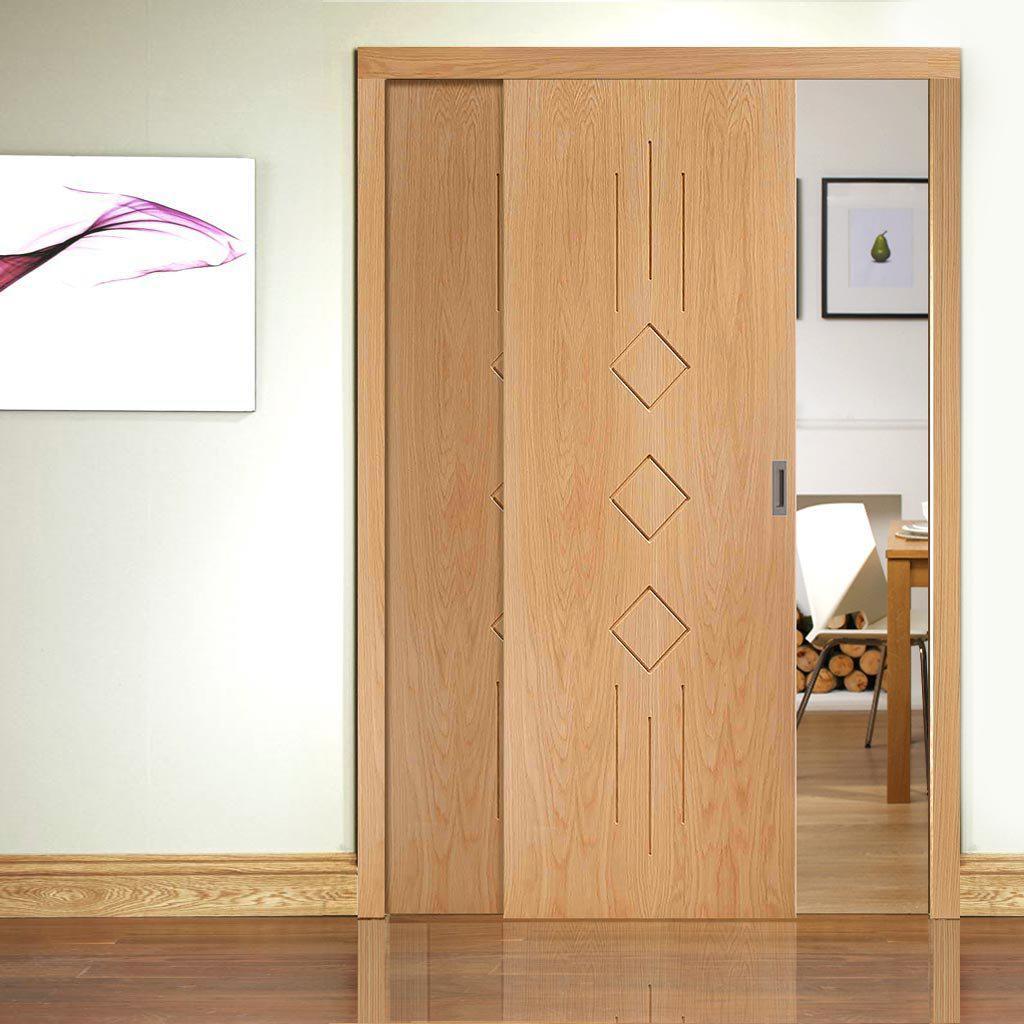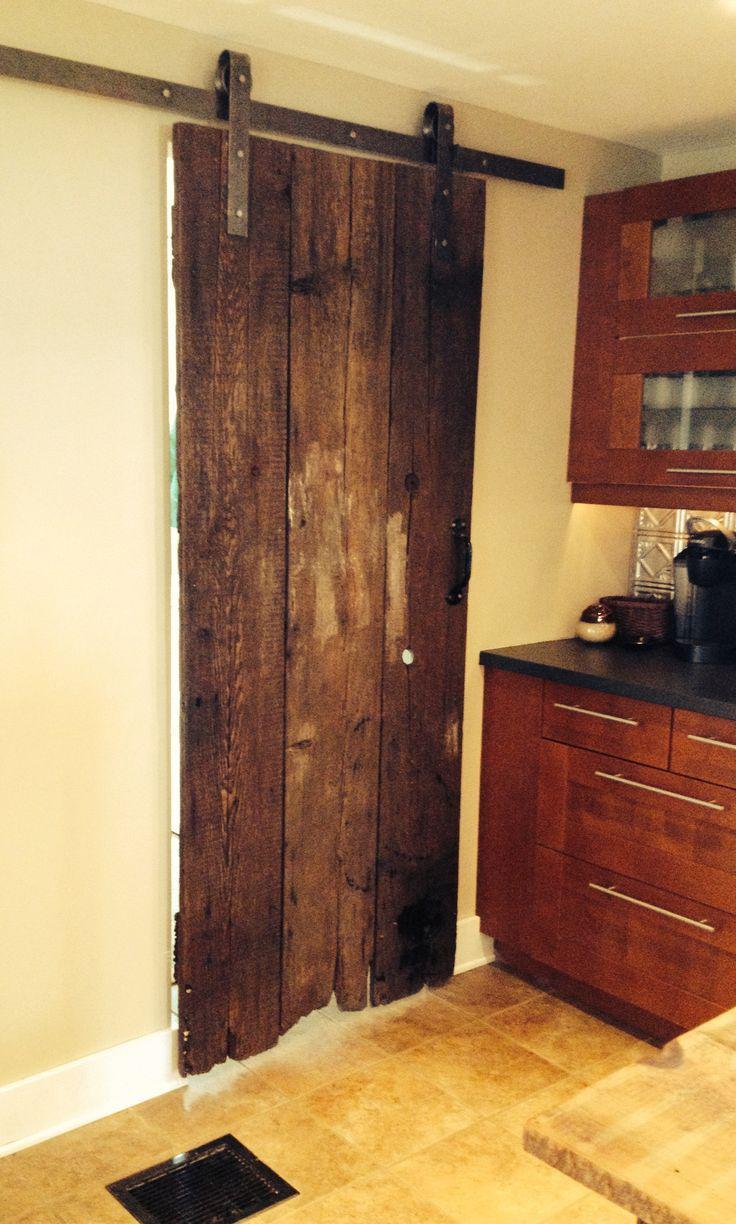The first image is the image on the left, the second image is the image on the right. Evaluate the accuracy of this statement regarding the images: "One image shows a sliding wood-grain door with a black horizontal band in the center.". Is it true? Answer yes or no. No. 